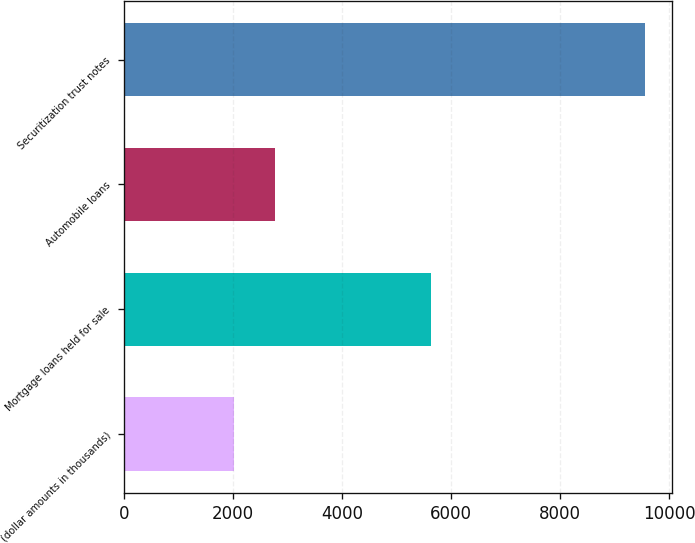Convert chart. <chart><loc_0><loc_0><loc_500><loc_500><bar_chart><fcel>(dollar amounts in thousands)<fcel>Mortgage loans held for sale<fcel>Automobile loans<fcel>Securitization trust notes<nl><fcel>2010<fcel>5633<fcel>2765.5<fcel>9565<nl></chart> 